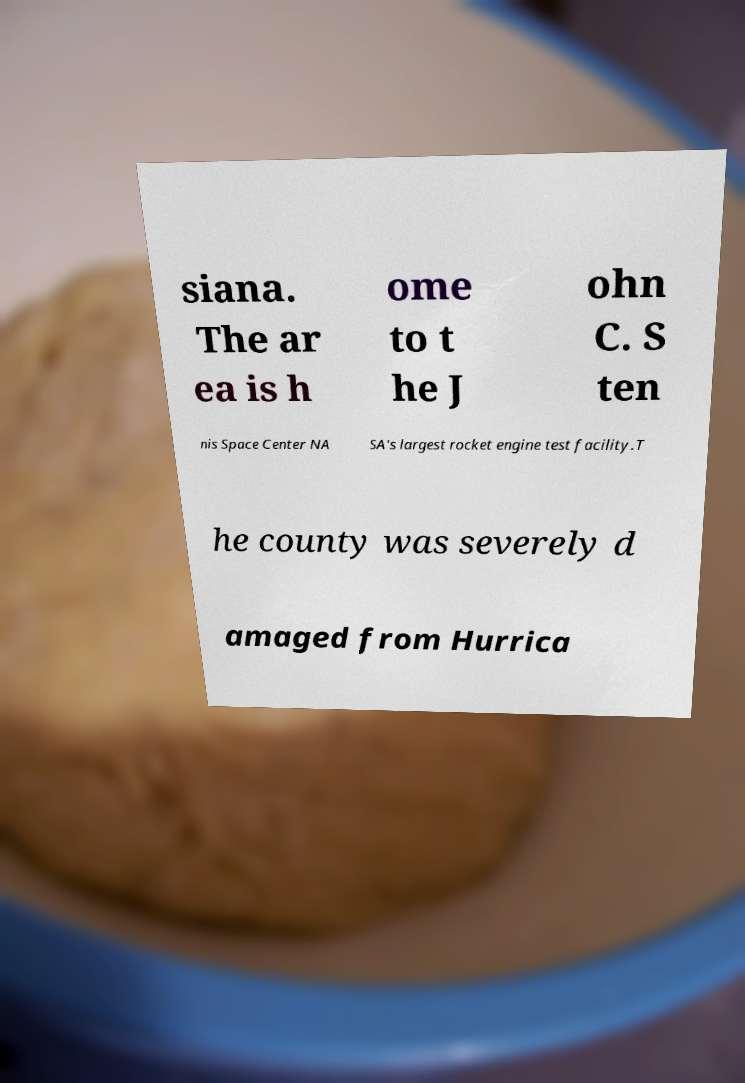Can you accurately transcribe the text from the provided image for me? siana. The ar ea is h ome to t he J ohn C. S ten nis Space Center NA SA's largest rocket engine test facility.T he county was severely d amaged from Hurrica 